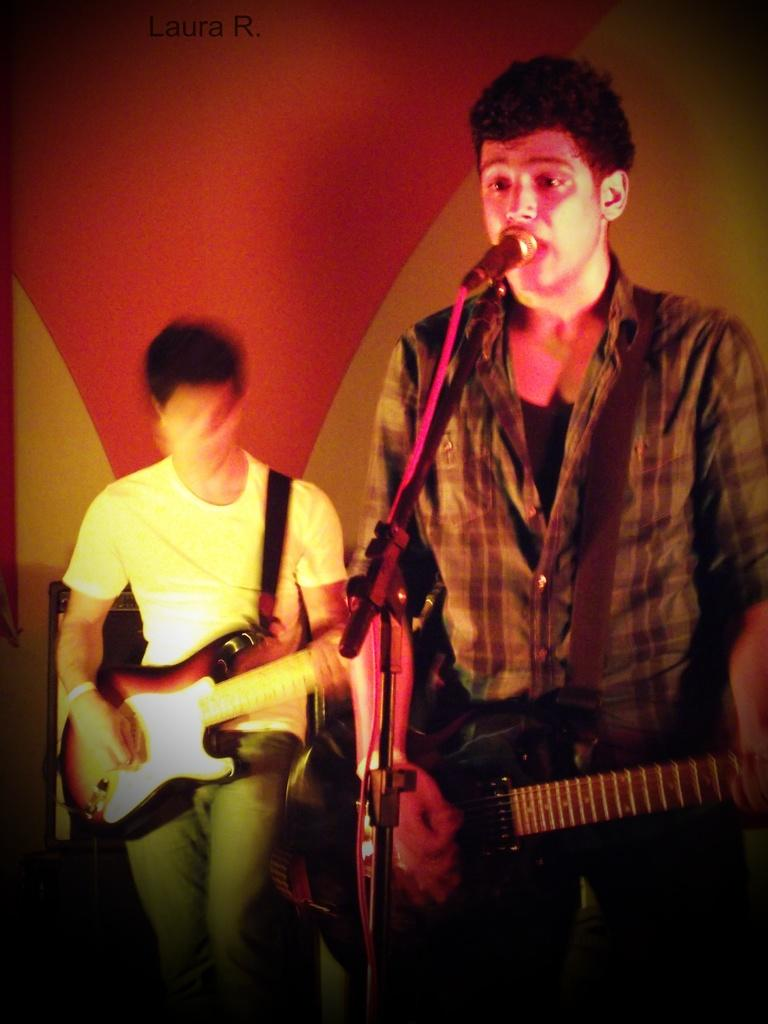How many people are in the image? There are two men in the image. What is one of the men holding? One of the men is holding a guitar. What is the other man standing near? The other man is standing in front of a microphone. What type of oranges can be seen in the image? There are no oranges present in the image. How does the heat affect the performance of the men in the image? There is no indication of heat or temperature in the image, so it cannot be determined effect on the men's performance. 